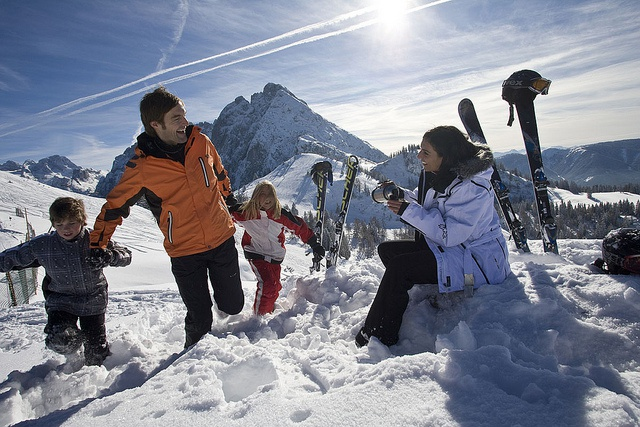Describe the objects in this image and their specific colors. I can see people in blue, black, brown, and maroon tones, people in blue, black, and gray tones, people in blue, black, gray, and maroon tones, people in blue, maroon, gray, and black tones, and skis in blue, black, gray, and darkgray tones in this image. 